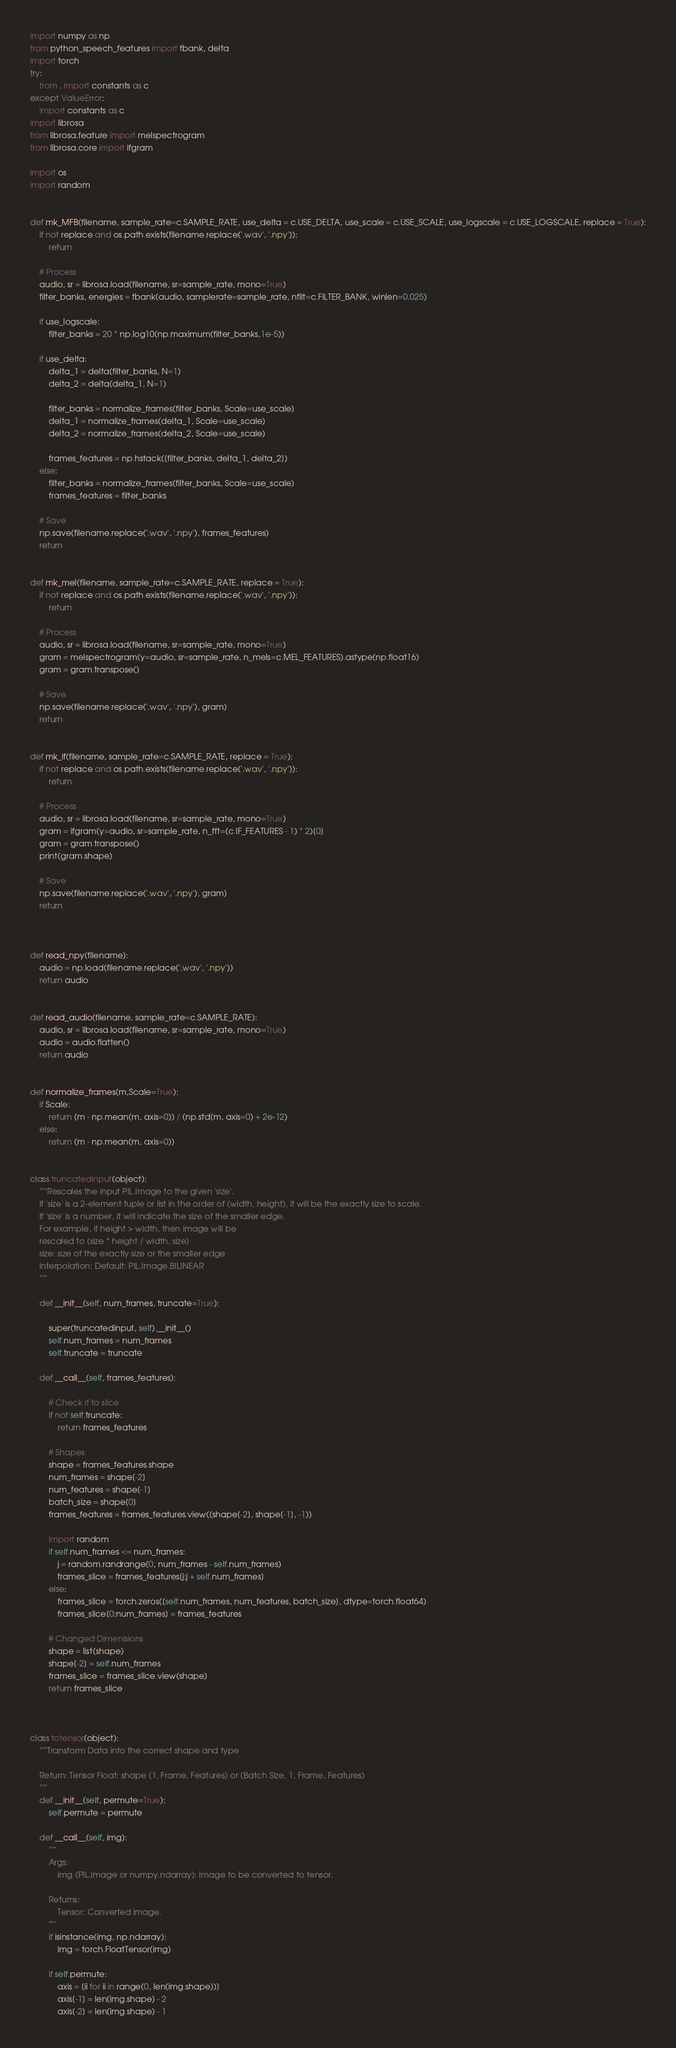<code> <loc_0><loc_0><loc_500><loc_500><_Python_>import numpy as np
from python_speech_features import fbank, delta
import torch
try:
    from . import constants as c
except ValueError:
    import constants as c
import librosa
from librosa.feature import melspectrogram
from librosa.core import ifgram

import os
import random


def mk_MFB(filename, sample_rate=c.SAMPLE_RATE, use_delta = c.USE_DELTA, use_scale = c.USE_SCALE, use_logscale = c.USE_LOGSCALE, replace = True):
    if not replace and os.path.exists(filename.replace('.wav', '.npy')):
        return

    # Process
    audio, sr = librosa.load(filename, sr=sample_rate, mono=True)
    filter_banks, energies = fbank(audio, samplerate=sample_rate, nfilt=c.FILTER_BANK, winlen=0.025)

    if use_logscale:
        filter_banks = 20 * np.log10(np.maximum(filter_banks,1e-5))

    if use_delta:
        delta_1 = delta(filter_banks, N=1)
        delta_2 = delta(delta_1, N=1)

        filter_banks = normalize_frames(filter_banks, Scale=use_scale)
        delta_1 = normalize_frames(delta_1, Scale=use_scale)
        delta_2 = normalize_frames(delta_2, Scale=use_scale)

        frames_features = np.hstack([filter_banks, delta_1, delta_2])
    else:
        filter_banks = normalize_frames(filter_banks, Scale=use_scale)
        frames_features = filter_banks

    # Save
    np.save(filename.replace('.wav', '.npy'), frames_features)
    return


def mk_mel(filename, sample_rate=c.SAMPLE_RATE, replace = True):
    if not replace and os.path.exists(filename.replace('.wav', '.npy')):
        return

    # Process
    audio, sr = librosa.load(filename, sr=sample_rate, mono=True)
    gram = melspectrogram(y=audio, sr=sample_rate, n_mels=c.MEL_FEATURES).astype(np.float16)
    gram = gram.transpose()

    # Save
    np.save(filename.replace('.wav', '.npy'), gram)
    return


def mk_if(filename, sample_rate=c.SAMPLE_RATE, replace = True):
    if not replace and os.path.exists(filename.replace('.wav', '.npy')):
        return

    # Process
    audio, sr = librosa.load(filename, sr=sample_rate, mono=True)
    gram = ifgram(y=audio, sr=sample_rate, n_fft=(c.IF_FEATURES - 1) * 2)[0]
    gram = gram.transpose()
    print(gram.shape)

    # Save
    np.save(filename.replace('.wav', '.npy'), gram)
    return



def read_npy(filename):
    audio = np.load(filename.replace('.wav', '.npy'))
    return audio


def read_audio(filename, sample_rate=c.SAMPLE_RATE):
    audio, sr = librosa.load(filename, sr=sample_rate, mono=True)
    audio = audio.flatten()
    return audio


def normalize_frames(m,Scale=True):
    if Scale:
        return (m - np.mean(m, axis=0)) / (np.std(m, axis=0) + 2e-12)
    else:
        return (m - np.mean(m, axis=0))


class truncatedinput(object):
    """Rescales the input PIL.Image to the given 'size'.
    If 'size' is a 2-element tuple or list in the order of (width, height), it will be the exactly size to scale.
    If 'size' is a number, it will indicate the size of the smaller edge.
    For example, if height > width, then image will be
    rescaled to (size * height / width, size)
    size: size of the exactly size or the smaller edge
    interpolation: Default: PIL.Image.BILINEAR
    """

    def __init__(self, num_frames, truncate=True):

        super(truncatedinput, self).__init__()
        self.num_frames = num_frames
        self.truncate = truncate

    def __call__(self, frames_features):
  
        # Check if to slice
        if not self.truncate:
            return frames_features

        # Shapes
        shape = frames_features.shape
        num_frames = shape[-2]
        num_features = shape[-1]
        batch_size = shape[0]
        frames_features = frames_features.view((shape[-2], shape[-1], -1))

        import random
        if self.num_frames <= num_frames:
            j = random.randrange(0, num_frames - self.num_frames)
            frames_slice = frames_features[j:j + self.num_frames]
        else:
            frames_slice = torch.zeros([self.num_frames, num_features, batch_size], dtype=torch.float64)
            frames_slice[0:num_frames] = frames_features

        # Changed Dimenisions
        shape = list(shape)
        shape[-2] = self.num_frames
        frames_slice = frames_slice.view(shape)
        return frames_slice



class totensor(object):
    """Transform Data into the correct shape and type
    
    Return: Tensor Float: shape (1, Frame, Features) or (Batch Size, 1, Frame, Features)
    """
    def __init__(self, permute=True):
        self.permute = permute

    def __call__(self, img):
        """
        Args:
            img (PIL.Image or numpy.ndarray): Image to be converted to tensor.

        Returns:
            Tensor: Converted image.
        """
        if isinstance(img, np.ndarray):
            img = torch.FloatTensor(img)

        if self.permute:
            axis = [ii for ii in range(0, len(img.shape))]
            axis[-1] = len(img.shape) - 2
            axis[-2] = len(img.shape) - 1</code> 